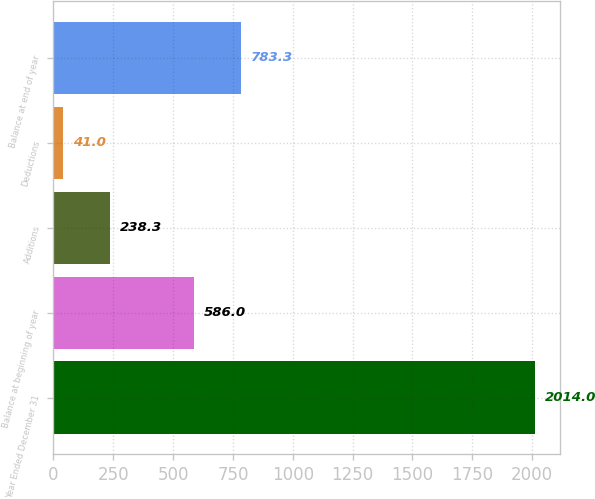<chart> <loc_0><loc_0><loc_500><loc_500><bar_chart><fcel>Year Ended December 31<fcel>Balance at beginning of year<fcel>Additions<fcel>Deductions<fcel>Balance at end of year<nl><fcel>2014<fcel>586<fcel>238.3<fcel>41<fcel>783.3<nl></chart> 